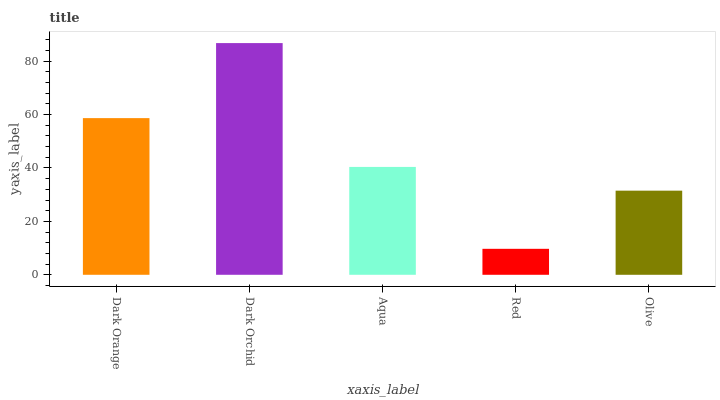Is Red the minimum?
Answer yes or no. Yes. Is Dark Orchid the maximum?
Answer yes or no. Yes. Is Aqua the minimum?
Answer yes or no. No. Is Aqua the maximum?
Answer yes or no. No. Is Dark Orchid greater than Aqua?
Answer yes or no. Yes. Is Aqua less than Dark Orchid?
Answer yes or no. Yes. Is Aqua greater than Dark Orchid?
Answer yes or no. No. Is Dark Orchid less than Aqua?
Answer yes or no. No. Is Aqua the high median?
Answer yes or no. Yes. Is Aqua the low median?
Answer yes or no. Yes. Is Dark Orchid the high median?
Answer yes or no. No. Is Dark Orange the low median?
Answer yes or no. No. 